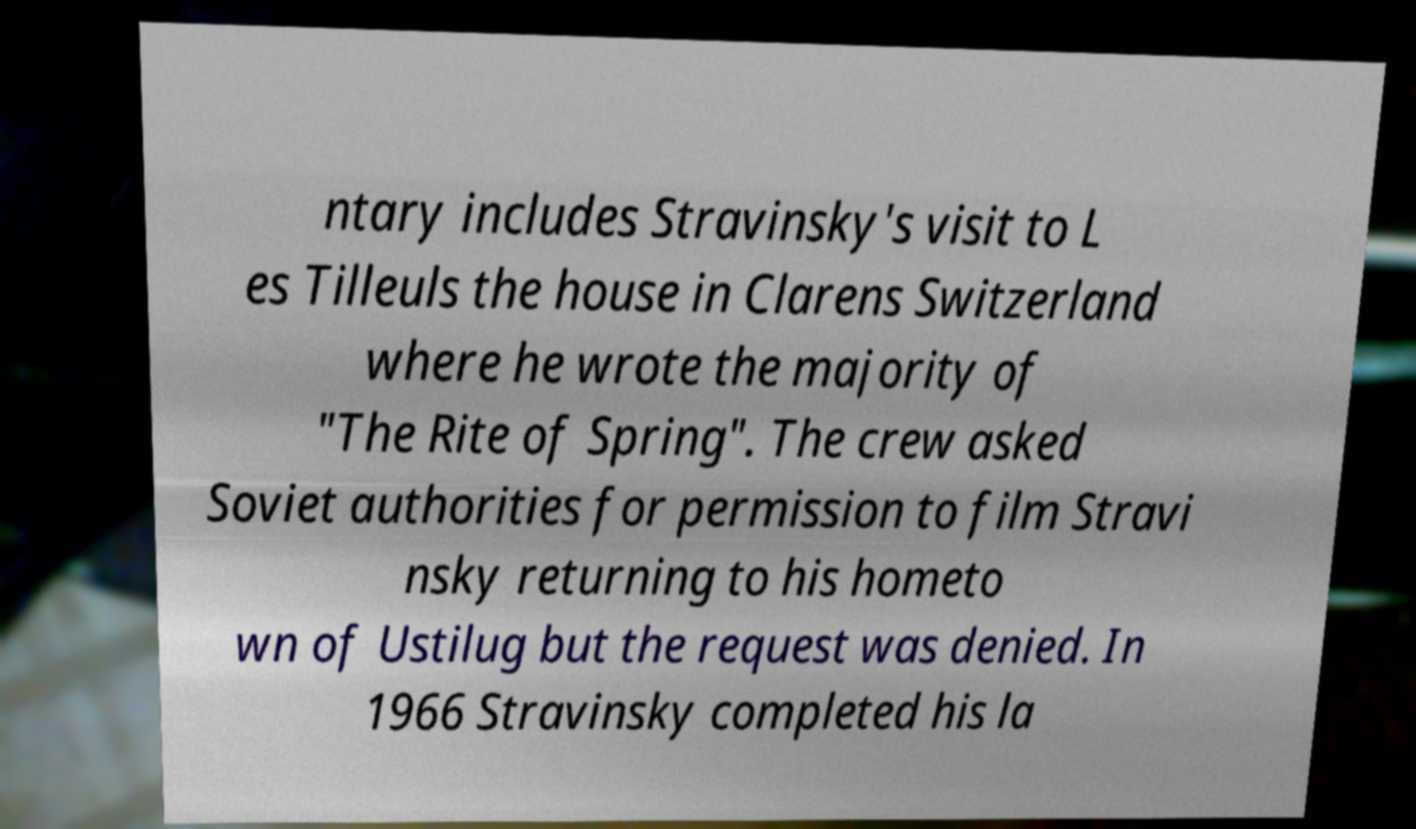I need the written content from this picture converted into text. Can you do that? ntary includes Stravinsky's visit to L es Tilleuls the house in Clarens Switzerland where he wrote the majority of "The Rite of Spring". The crew asked Soviet authorities for permission to film Stravi nsky returning to his hometo wn of Ustilug but the request was denied. In 1966 Stravinsky completed his la 